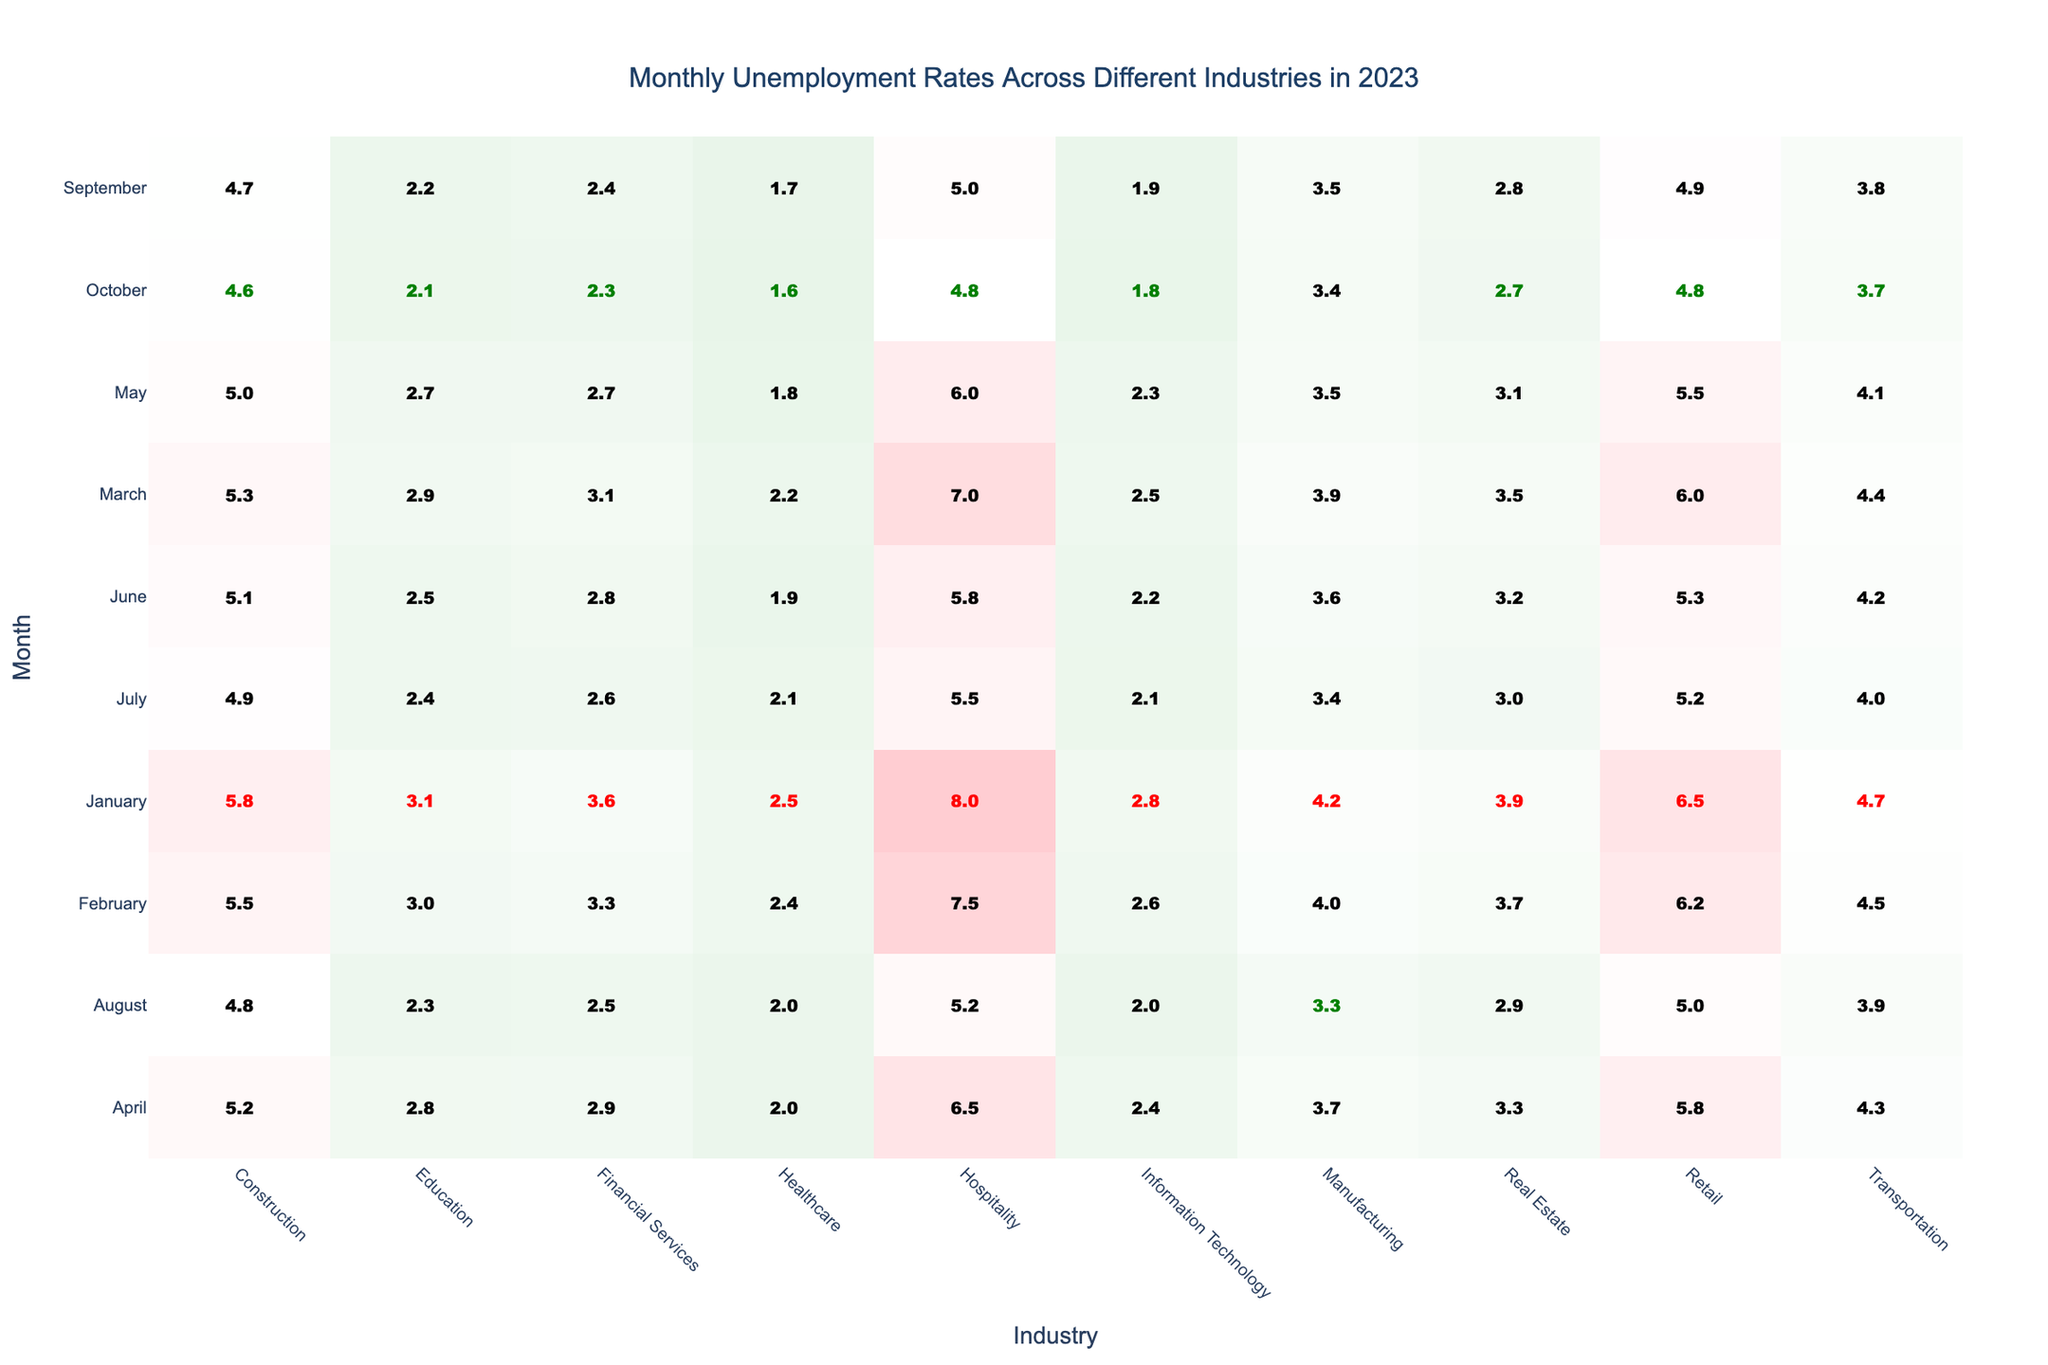What was the highest unemployment rate in the Hospitality industry during 2023? By examining the table for the Hospitality industry, the maximum unemployment rate recorded is 8.0% in January.
Answer: 8.0% Which industry consistently had the lowest unemployment rate throughout the year? Looking at the Healthcare industry across all months, it had the lowest unemployment rates, starting at 2.5% in January and reaching a low of 1.6% in October.
Answer: Healthcare What was the average unemployment rate in the Retail industry for the first half of the year (January to June)? The unemployment rates in the Retail industry from January to June are: 6.5%, 6.2%, 6.0%, 5.8%, 5.5%, 5.3%. Summing these (6.5 + 6.2 + 6.0 + 5.8 + 5.5 + 5.3 = 34.3) and dividing by 6 gives an average of 5.72%.
Answer: 5.72% Which month showed the most significant decline in unemployment in the Construction industry from January to October? Comparing the unemployment rates in the Construction industry from January (5.8%) to October (4.6%), we see a decline of 1.2%. This decline is consistent when looking at all months, confirming October's rate as the lowest.
Answer: October Did the Financial Services industry ever record an unemployment rate below 2.5% in any month during 2023? Checking the table for the Financial Services industry, it shows the lowest rate was 2.3% in October, which is indeed below 2.5%.
Answer: Yes What is the difference between the highest and lowest unemployment rates in the Transportation industry for the year? The highest unemployment rate in the Transportation industry is 4.7% (January), and the lowest is 3.7% (October). The difference is 4.7% - 3.7% = 1.0%.
Answer: 1.0% Which month had the highest unemployment rate in the Construction industry, and what was that rate? Analyzing the Construction industry month by month, the highest recorded rate was 5.8% in January.
Answer: January, 5.8% Does the Retail industry show a trend towards improvement in unemployment rates as the year progresses? By reviewing the Retail industry rates from January to October, the trend shows a decrease from 6.5% to 4.8%, indicating an improvement over the months.
Answer: Yes Which industry experienced the largest reduction in unemployment rates from January to October? Evaluating the rates for each industry from January to October, the Construction industry decreased from 5.8% to 4.6%, reflecting a 1.2% reduction, which is the largest among the industries.
Answer: Construction Was there any month where the unemployment rate in the Information Technology industry dropped below 2%? By reviewing the Information Technology industry data, the lowest rate was 1.8% in October, which is indeed below 2%.
Answer: Yes 